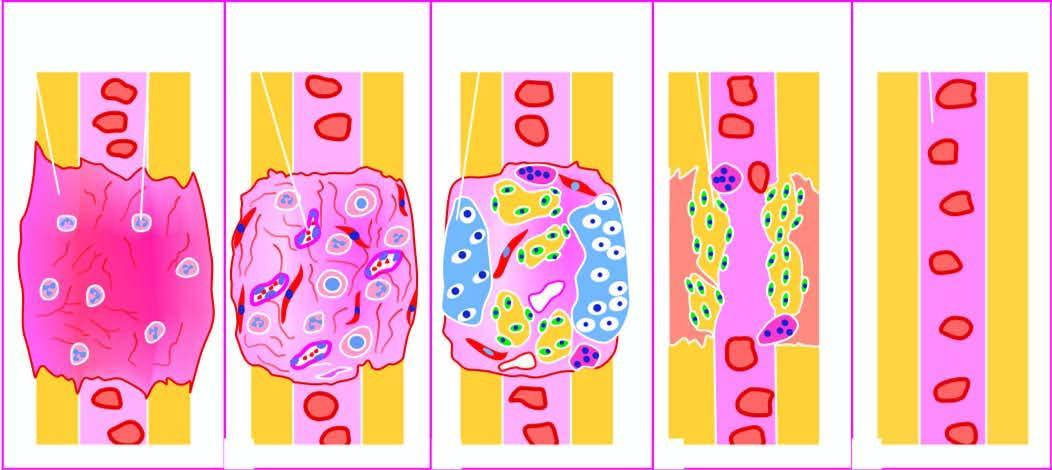what is converted into lamellar bone and internal callus developing bone marrow cavity?
Answer the question using a single word or phrase. Intermediate callus 